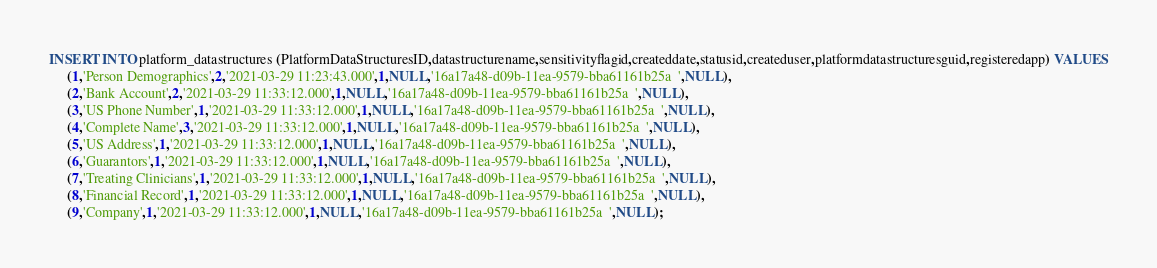<code> <loc_0><loc_0><loc_500><loc_500><_SQL_>INSERT INTO platform_datastructures (PlatformDataStructuresID,datastructurename,sensitivityflagid,createddate,statusid,createduser,platformdatastructuresguid,registeredapp) VALUES
	 (1,'Person Demographics',2,'2021-03-29 11:23:43.000',1,NULL,'16a17a48-d09b-11ea-9579-bba61161b25a  ',NULL),
	 (2,'Bank Account',2,'2021-03-29 11:33:12.000',1,NULL,'16a17a48-d09b-11ea-9579-bba61161b25a  ',NULL),
	 (3,'US Phone Number',1,'2021-03-29 11:33:12.000',1,NULL,'16a17a48-d09b-11ea-9579-bba61161b25a  ',NULL),
	 (4,'Complete Name',3,'2021-03-29 11:33:12.000',1,NULL,'16a17a48-d09b-11ea-9579-bba61161b25a  ',NULL),	
	 (5,'US Address',1,'2021-03-29 11:33:12.000',1,NULL,'16a17a48-d09b-11ea-9579-bba61161b25a  ',NULL),
	 (6,'Guarantors',1,'2021-03-29 11:33:12.000',1,NULL,'16a17a48-d09b-11ea-9579-bba61161b25a  ',NULL),
	 (7,'Treating Clinicians',1,'2021-03-29 11:33:12.000',1,NULL,'16a17a48-d09b-11ea-9579-bba61161b25a  ',NULL),
     (8,'Financial Record',1,'2021-03-29 11:33:12.000',1,NULL,'16a17a48-d09b-11ea-9579-bba61161b25a  ',NULL),
	 (9,'Company',1,'2021-03-29 11:33:12.000',1,NULL,'16a17a48-d09b-11ea-9579-bba61161b25a  ',NULL);
</code> 